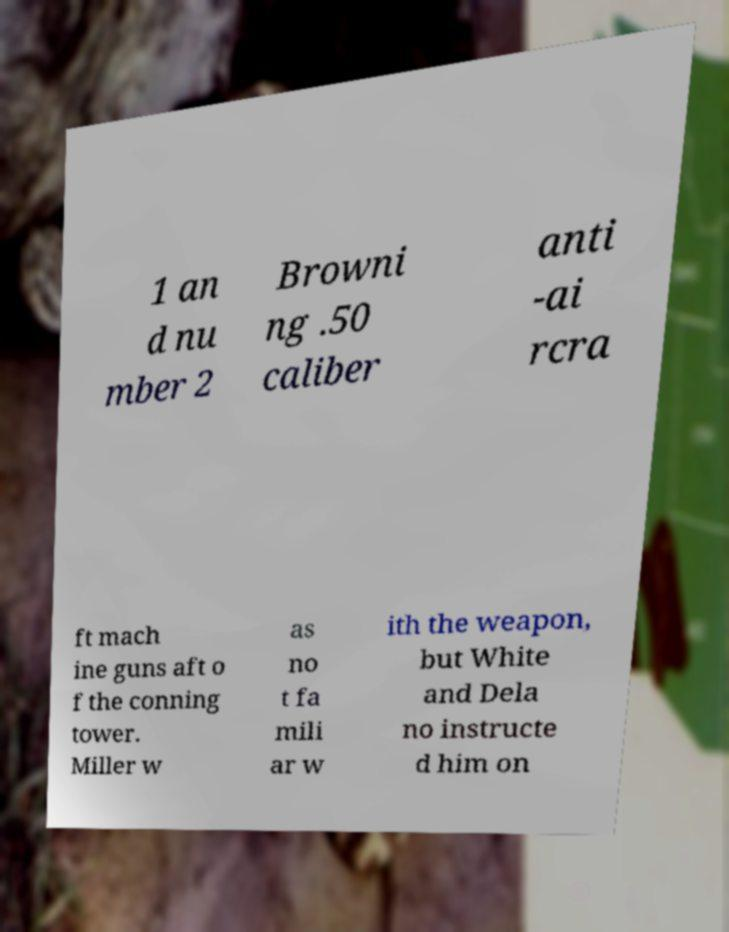Can you accurately transcribe the text from the provided image for me? 1 an d nu mber 2 Browni ng .50 caliber anti -ai rcra ft mach ine guns aft o f the conning tower. Miller w as no t fa mili ar w ith the weapon, but White and Dela no instructe d him on 